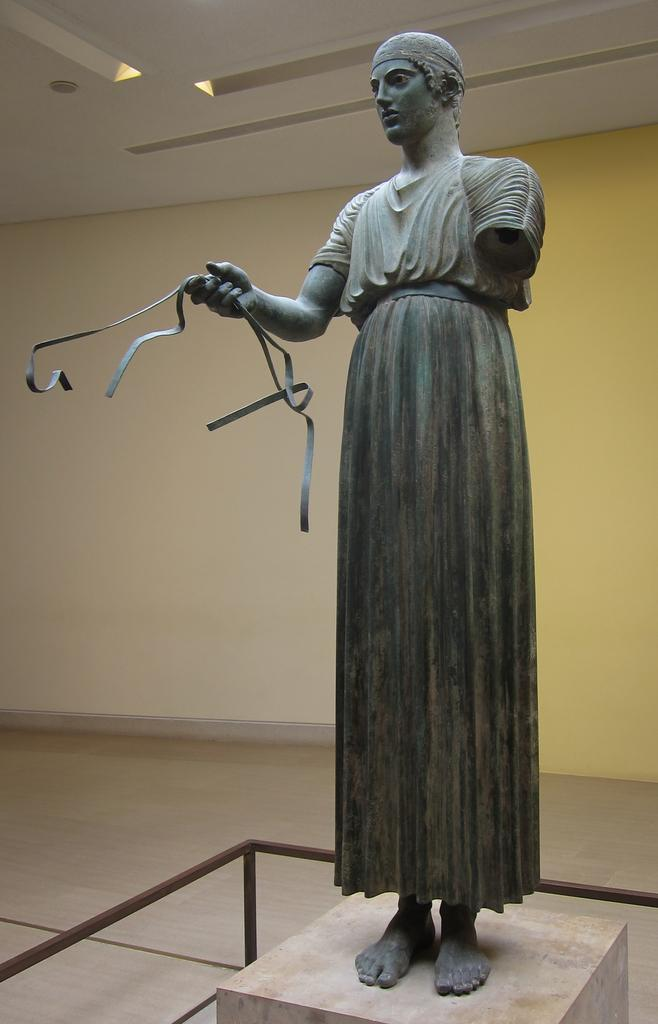What is the main subject in the image? There is a statue in the image. What surrounds the statue? There is an iron frame around the statue. What part of the room or building can be seen at the top of the image? The ceiling is visible at the top of the image. What can be seen in the background of the image? There is a well in the background of the image. How many snails are crawling on the statue in the image? There are no snails present on the statue in the image. What type of currency is being exchanged near the well in the background? There is no exchange of money or currency depicted in the image. 